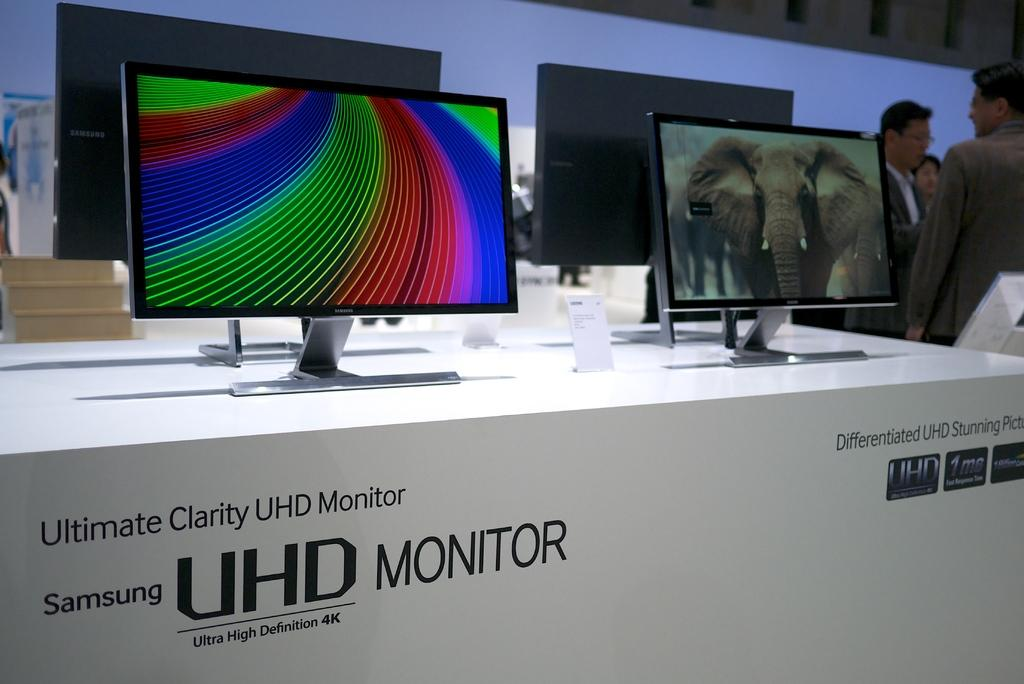<image>
Offer a succinct explanation of the picture presented. a box for the samsung uhd monitor and setup screens displayed on top 